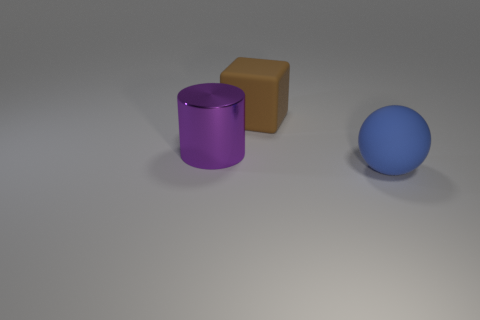How many big blue objects are left of the big matte thing in front of the large rubber object behind the large rubber sphere?
Ensure brevity in your answer.  0. Is the size of the purple shiny object the same as the rubber object that is behind the purple shiny thing?
Offer a terse response. Yes. How many big red objects are there?
Ensure brevity in your answer.  0. There is a thing that is behind the cylinder; does it have the same size as the object that is to the right of the large brown block?
Keep it short and to the point. Yes. Is the shape of the big shiny object the same as the big brown matte object?
Offer a very short reply. No. What number of big balls have the same material as the big block?
Your response must be concise. 1. How many objects are either large gray metal spheres or large rubber objects?
Keep it short and to the point. 2. Is there a big cylinder in front of the big thing behind the big cylinder?
Offer a terse response. Yes. Are there more matte spheres in front of the blue rubber ball than rubber objects behind the shiny thing?
Provide a short and direct response. No. What number of matte things have the same color as the large rubber sphere?
Provide a short and direct response. 0. 